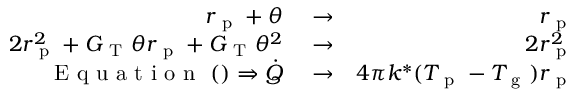<formula> <loc_0><loc_0><loc_500><loc_500>\begin{array} { r l r } { r _ { p } + \theta } & \rightarrow } & { r _ { p } } \\ { 2 r _ { p } ^ { 2 } + G _ { T } \theta r _ { p } + G _ { T } \theta ^ { 2 } } & \rightarrow } & { 2 r _ { p } ^ { 2 } } \\ { E q u a t i o n ( ) \Rightarrow \dot { Q } } & \rightarrow } & { 4 \pi k ^ { * } ( T _ { p } - T _ { g } ) r _ { p } } \end{array}</formula> 